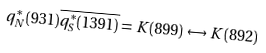<formula> <loc_0><loc_0><loc_500><loc_500>q _ { N } ^ { \ast } ( 9 3 1 ) \overline { { { q _ { S } ^ { \ast } ( 1 3 9 1 ) } } } = K ( 8 9 9 ) \leftrightarrow K ( 8 9 2 )</formula> 